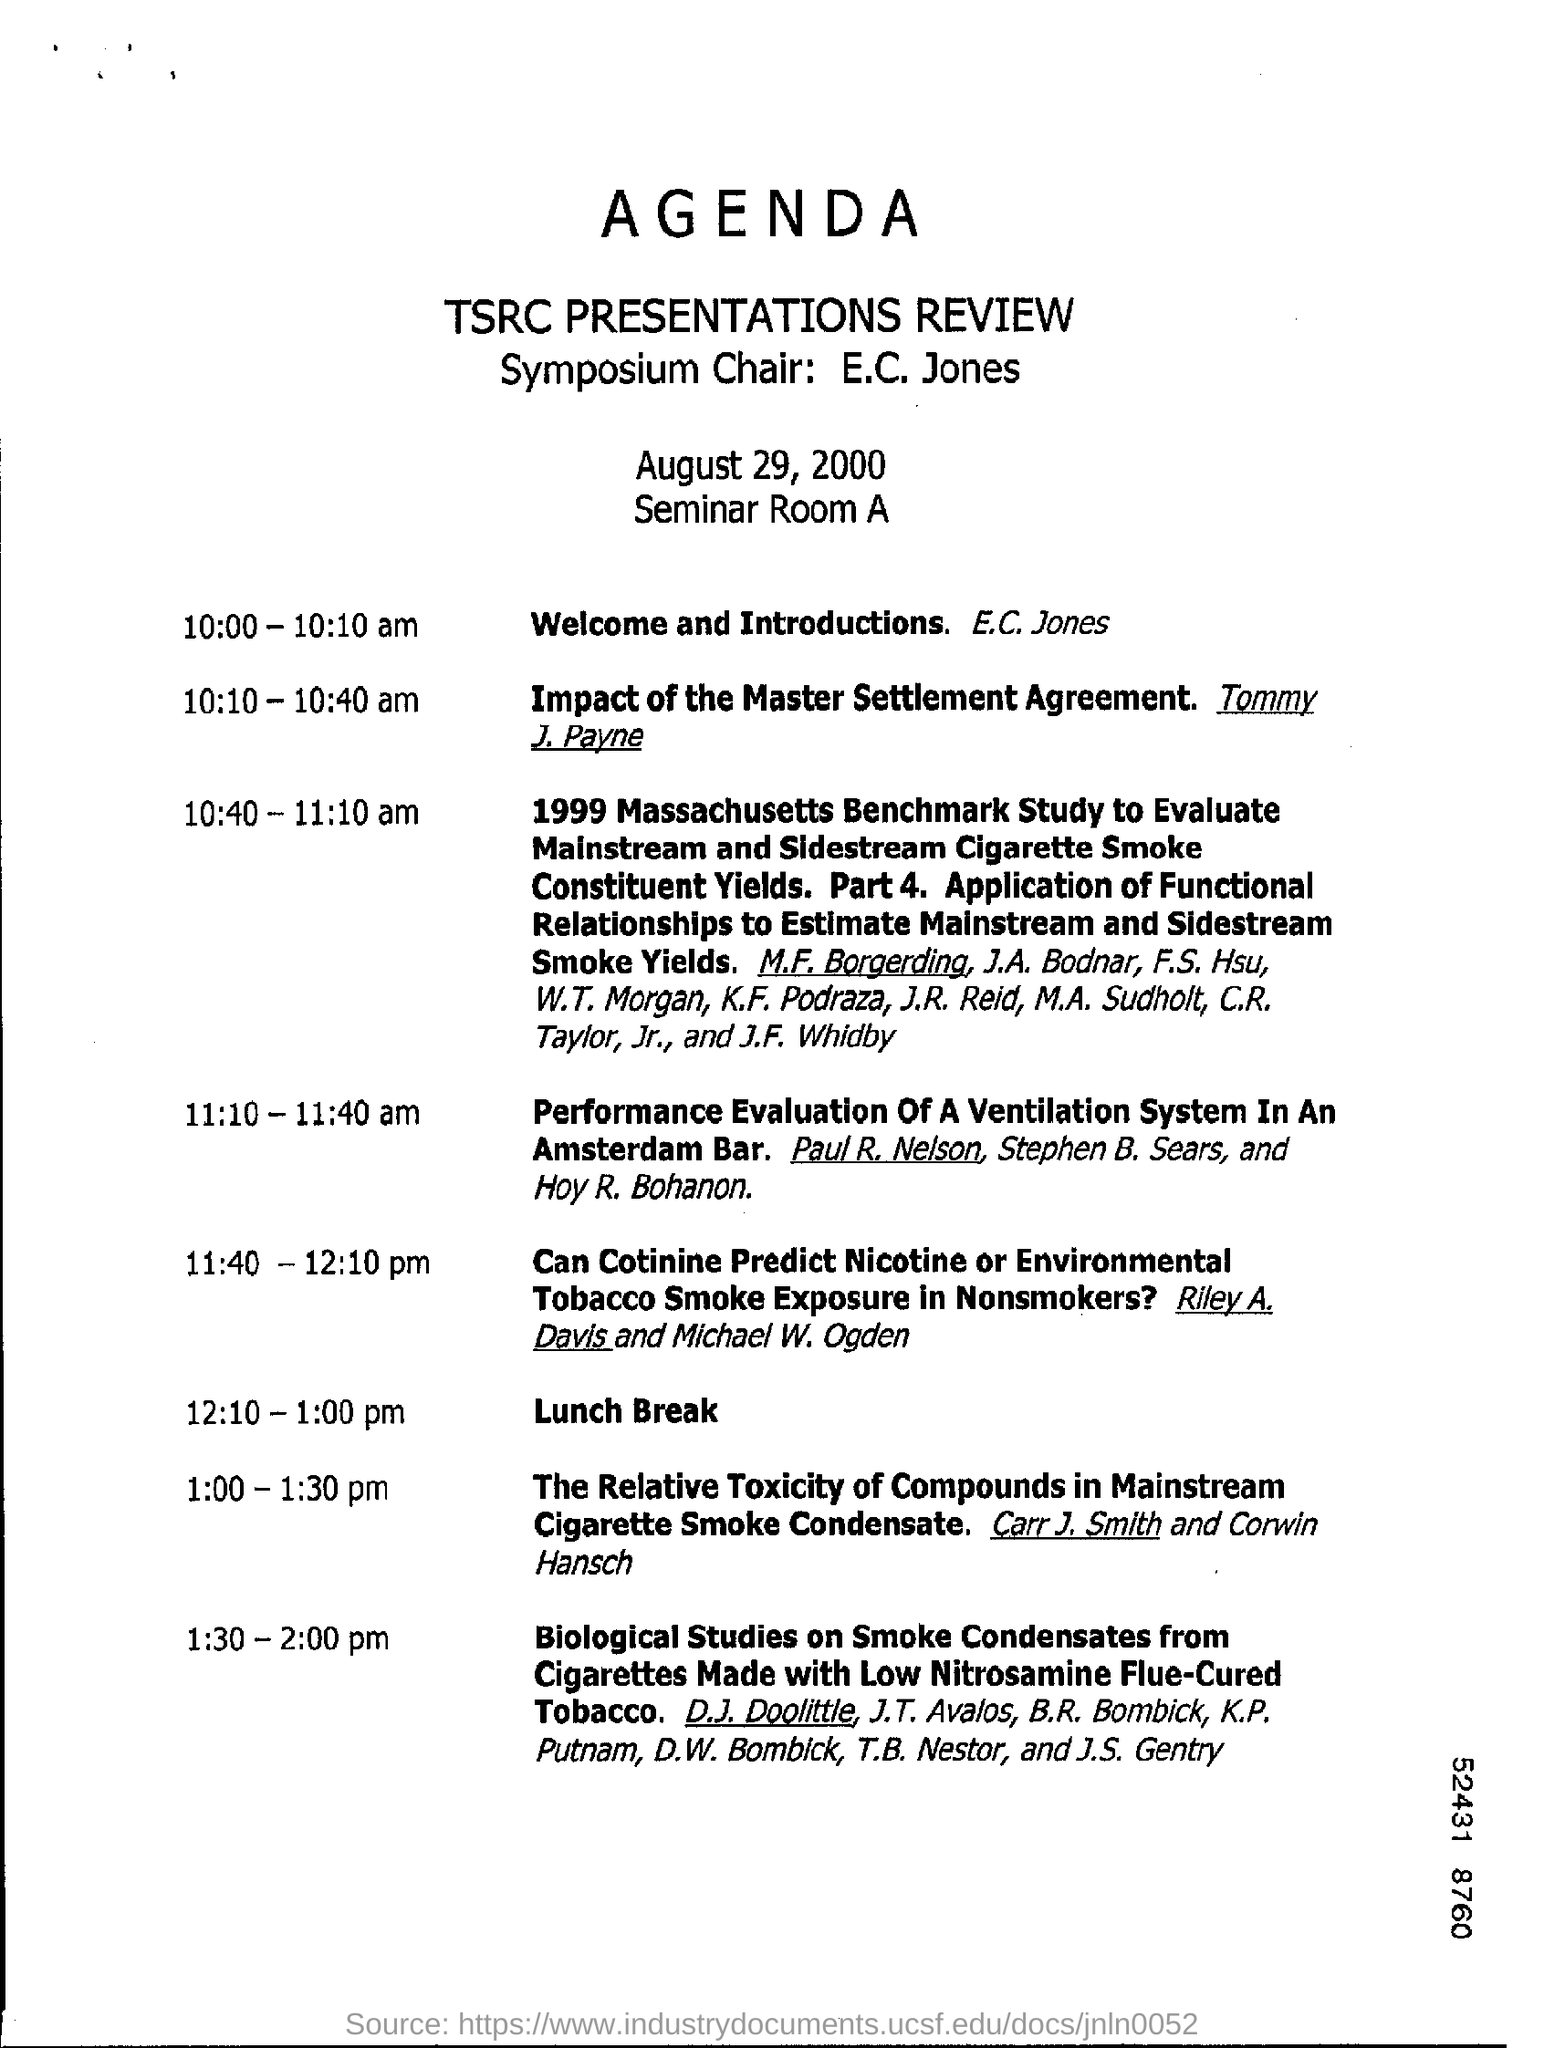Who is conducting the session at 10:10 - 10:40 am ?
Offer a terse response. Tommy J. Payne. At what time is the lunch break provided?
Provide a short and direct response. 12.10 - 1.00 pm. 